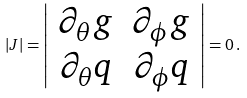Convert formula to latex. <formula><loc_0><loc_0><loc_500><loc_500>| J | = \left | \begin{array} { c c } { \partial _ { \theta } g } & { \partial _ { \phi } g } \\ { \partial _ { \theta } q } & { \partial _ { \phi } q } \end{array} \right | = 0 \, .</formula> 